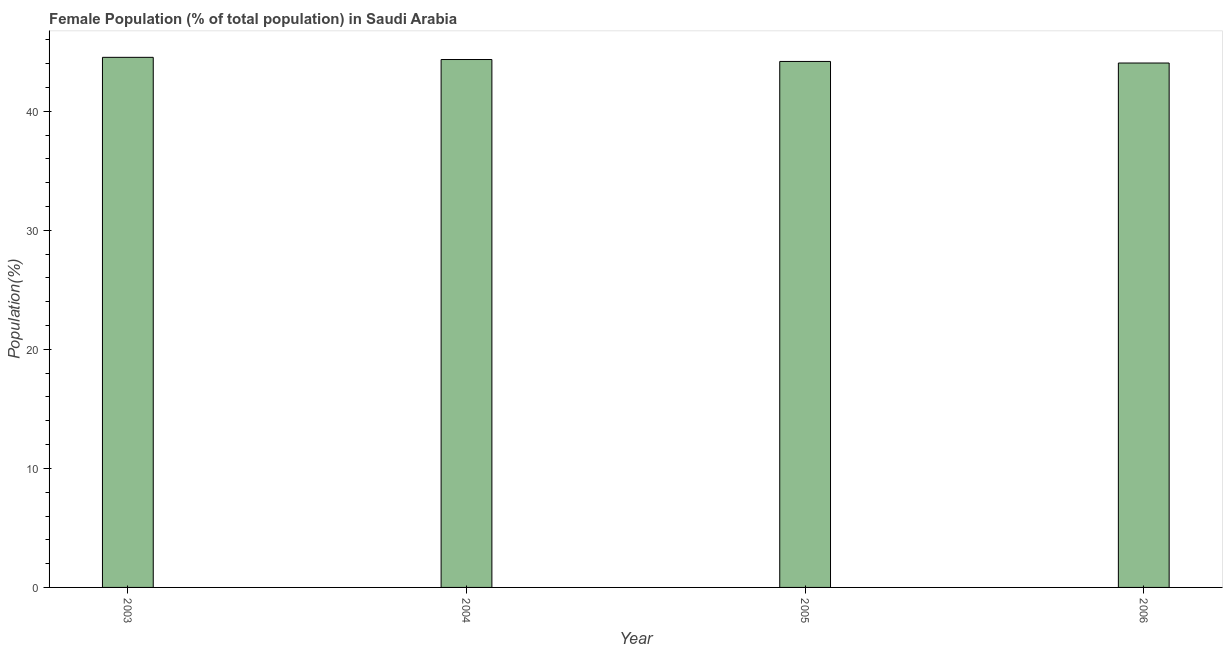Does the graph contain any zero values?
Your response must be concise. No. Does the graph contain grids?
Give a very brief answer. No. What is the title of the graph?
Make the answer very short. Female Population (% of total population) in Saudi Arabia. What is the label or title of the Y-axis?
Offer a terse response. Population(%). What is the female population in 2006?
Offer a terse response. 44.06. Across all years, what is the maximum female population?
Provide a succinct answer. 44.54. Across all years, what is the minimum female population?
Your response must be concise. 44.06. In which year was the female population maximum?
Offer a terse response. 2003. What is the sum of the female population?
Offer a very short reply. 177.13. What is the difference between the female population in 2004 and 2006?
Offer a very short reply. 0.29. What is the average female population per year?
Your answer should be very brief. 44.28. What is the median female population?
Offer a very short reply. 44.27. In how many years, is the female population greater than 8 %?
Offer a very short reply. 4. Do a majority of the years between 2006 and 2004 (inclusive) have female population greater than 30 %?
Keep it short and to the point. Yes. Is the female population in 2004 less than that in 2006?
Provide a succinct answer. No. What is the difference between the highest and the second highest female population?
Offer a terse response. 0.18. Is the sum of the female population in 2005 and 2006 greater than the maximum female population across all years?
Your answer should be very brief. Yes. What is the difference between the highest and the lowest female population?
Your answer should be very brief. 0.48. In how many years, is the female population greater than the average female population taken over all years?
Ensure brevity in your answer.  2. Are all the bars in the graph horizontal?
Keep it short and to the point. No. How many years are there in the graph?
Give a very brief answer. 4. Are the values on the major ticks of Y-axis written in scientific E-notation?
Your answer should be very brief. No. What is the Population(%) of 2003?
Give a very brief answer. 44.54. What is the Population(%) of 2004?
Offer a terse response. 44.35. What is the Population(%) of 2005?
Your answer should be very brief. 44.19. What is the Population(%) in 2006?
Make the answer very short. 44.06. What is the difference between the Population(%) in 2003 and 2004?
Provide a short and direct response. 0.18. What is the difference between the Population(%) in 2003 and 2005?
Your answer should be very brief. 0.35. What is the difference between the Population(%) in 2003 and 2006?
Offer a very short reply. 0.48. What is the difference between the Population(%) in 2004 and 2005?
Ensure brevity in your answer.  0.16. What is the difference between the Population(%) in 2004 and 2006?
Your answer should be compact. 0.29. What is the difference between the Population(%) in 2005 and 2006?
Your answer should be very brief. 0.13. What is the ratio of the Population(%) in 2003 to that in 2004?
Your response must be concise. 1. What is the ratio of the Population(%) in 2003 to that in 2005?
Provide a succinct answer. 1.01. What is the ratio of the Population(%) in 2003 to that in 2006?
Keep it short and to the point. 1.01. What is the ratio of the Population(%) in 2004 to that in 2005?
Keep it short and to the point. 1. What is the ratio of the Population(%) in 2004 to that in 2006?
Offer a terse response. 1.01. What is the ratio of the Population(%) in 2005 to that in 2006?
Give a very brief answer. 1. 